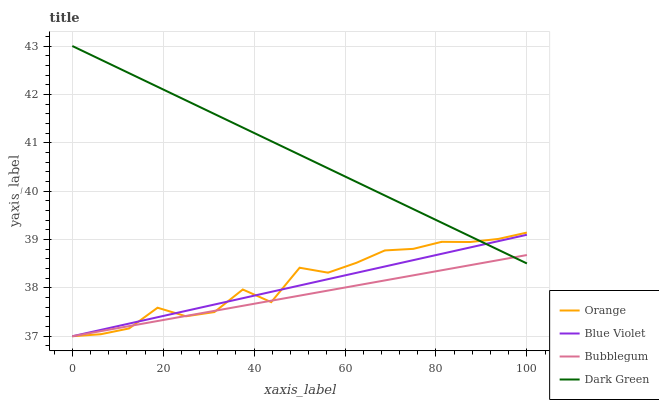Does Bubblegum have the minimum area under the curve?
Answer yes or no. Yes. Does Dark Green have the maximum area under the curve?
Answer yes or no. Yes. Does Blue Violet have the minimum area under the curve?
Answer yes or no. No. Does Blue Violet have the maximum area under the curve?
Answer yes or no. No. Is Blue Violet the smoothest?
Answer yes or no. Yes. Is Orange the roughest?
Answer yes or no. Yes. Is Bubblegum the smoothest?
Answer yes or no. No. Is Bubblegum the roughest?
Answer yes or no. No. Does Orange have the lowest value?
Answer yes or no. Yes. Does Dark Green have the lowest value?
Answer yes or no. No. Does Dark Green have the highest value?
Answer yes or no. Yes. Does Blue Violet have the highest value?
Answer yes or no. No. Does Blue Violet intersect Bubblegum?
Answer yes or no. Yes. Is Blue Violet less than Bubblegum?
Answer yes or no. No. Is Blue Violet greater than Bubblegum?
Answer yes or no. No. 